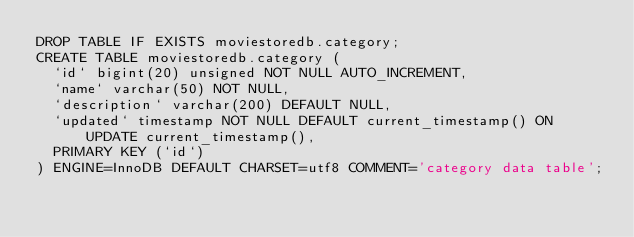<code> <loc_0><loc_0><loc_500><loc_500><_SQL_>DROP TABLE IF EXISTS moviestoredb.category;
CREATE TABLE moviestoredb.category (
  `id` bigint(20) unsigned NOT NULL AUTO_INCREMENT,
  `name` varchar(50) NOT NULL,
  `description` varchar(200) DEFAULT NULL,
  `updated` timestamp NOT NULL DEFAULT current_timestamp() ON UPDATE current_timestamp(),
  PRIMARY KEY (`id`)
) ENGINE=InnoDB DEFAULT CHARSET=utf8 COMMENT='category data table';
</code> 